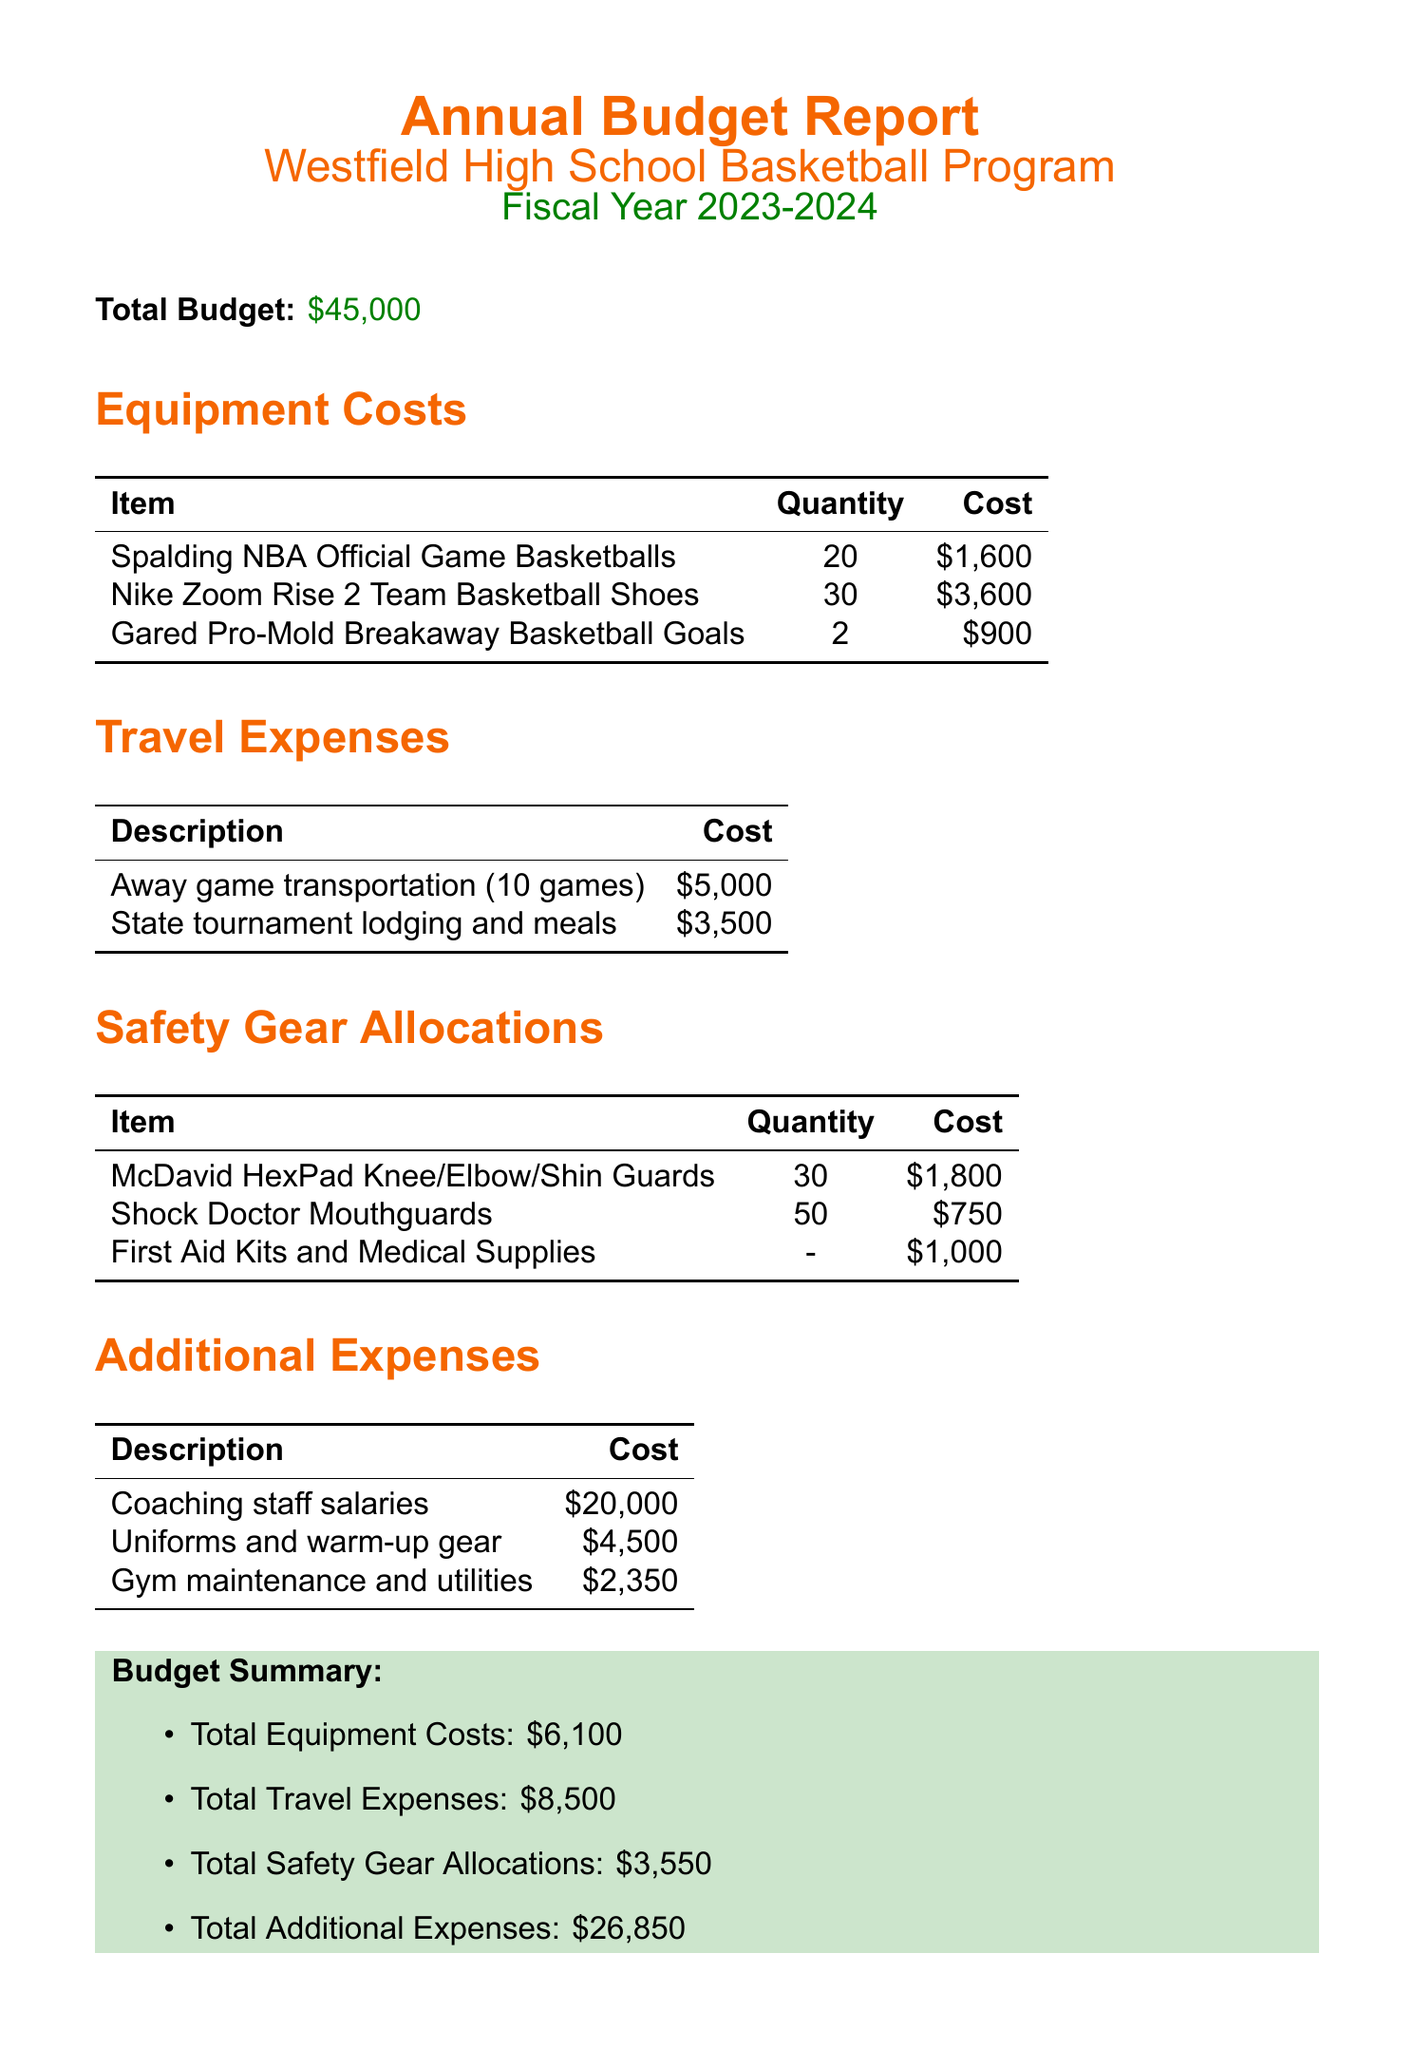What is the total budget for the basketball program? The total budget is explicitly stated in the document as \$45,000.
Answer: \$45,000 How much is allocated for away game transportation? The document lists the cost for away game transportation as \$5,000 under travel expenses.
Answer: \$5,000 What item is allocated for safety gear and costs \$1,000? The document mentions that First Aid Kits and Medical Supplies cost \$1,000 under safety gear allocations.
Answer: First Aid Kits and Medical Supplies What is the total cost of safety gear allocations? The total safety gear allocations are summarized in the document as \$3,550.
Answer: \$3,550 How many basketball shoes are budgeted to be purchased? The document states that 30 pairs of Nike Zoom Rise 2 Team Basketball Shoes are budgeted for purchase under equipment costs.
Answer: 30 How much is the total spent on coaching staff salaries? The document indicates that coaching staff salaries cost \$20,000 under additional expenses.
Answer: \$20,000 What is the total equipment cost listed in the budget summary? The budget summary specifies that total equipment costs amount to \$6,100.
Answer: \$6,100 What percentage of the total budget is allocated for travel expenses? The total travel expenses, \$8,500, can be calculated as a percentage of the total budget by dividing \$8,500 by \$45,000 and multiplying by 100. This results in approximately 18.89%.
Answer: 18.89% What item is listed with the highest quantity in safety gear? The document details that there are 50 Shock Doctor Mouthguards allocated under safety gear, making it the item with the highest quantity.
Answer: Shock Doctor Mouthguards 